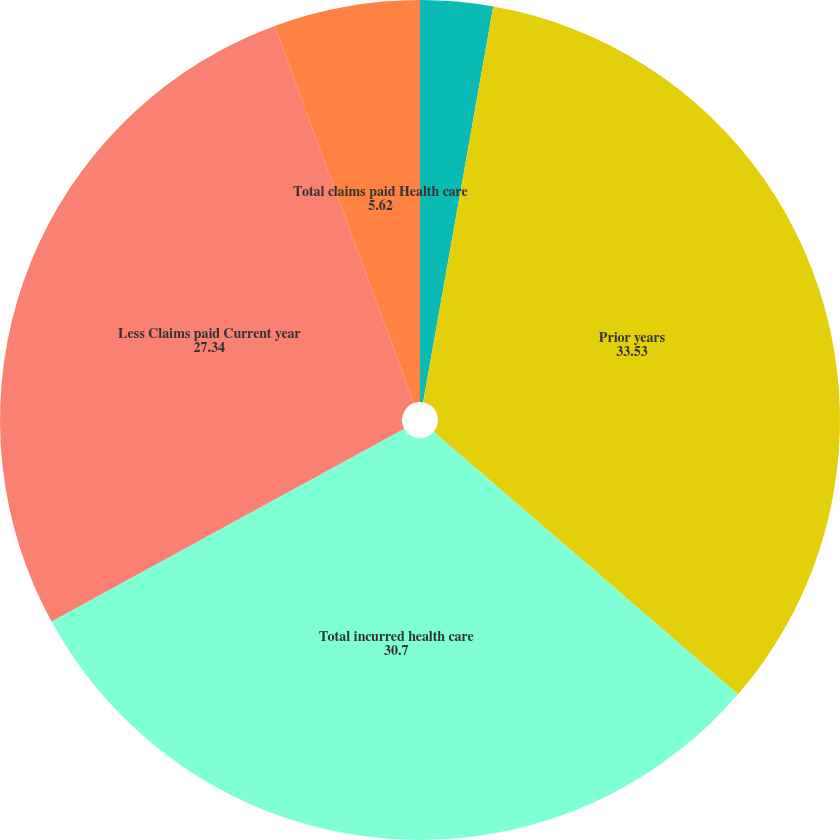Convert chart. <chart><loc_0><loc_0><loc_500><loc_500><pie_chart><fcel>Health care costs payable<fcel>Prior years<fcel>Total incurred health care<fcel>Less Claims paid Current year<fcel>Total claims paid Health care<nl><fcel>2.79%<fcel>33.53%<fcel>30.7%<fcel>27.34%<fcel>5.62%<nl></chart> 